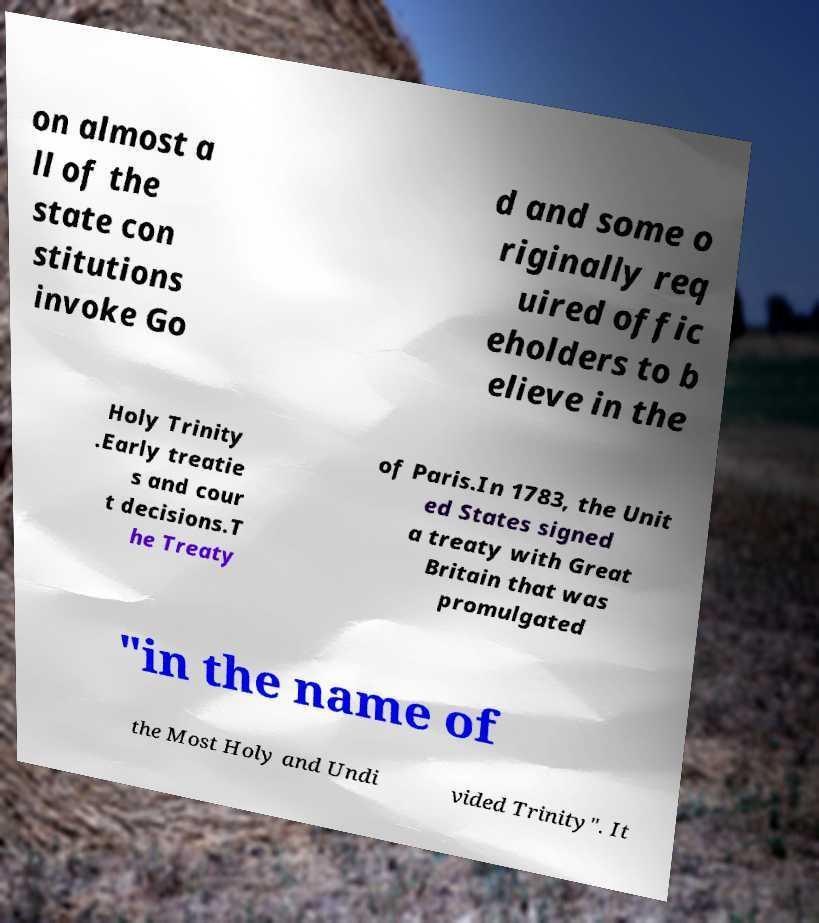What messages or text are displayed in this image? I need them in a readable, typed format. on almost a ll of the state con stitutions invoke Go d and some o riginally req uired offic eholders to b elieve in the Holy Trinity .Early treatie s and cour t decisions.T he Treaty of Paris.In 1783, the Unit ed States signed a treaty with Great Britain that was promulgated "in the name of the Most Holy and Undi vided Trinity". It 